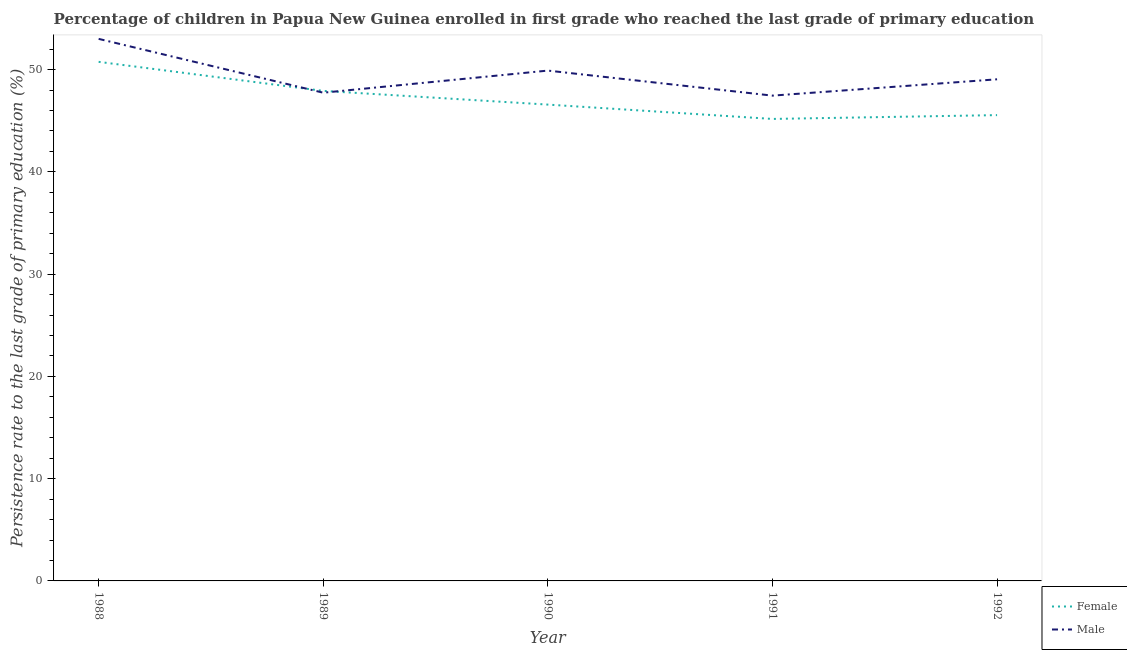What is the persistence rate of female students in 1988?
Your response must be concise. 50.76. Across all years, what is the maximum persistence rate of female students?
Your answer should be compact. 50.76. Across all years, what is the minimum persistence rate of female students?
Ensure brevity in your answer.  45.18. In which year was the persistence rate of female students maximum?
Your answer should be very brief. 1988. In which year was the persistence rate of male students minimum?
Give a very brief answer. 1991. What is the total persistence rate of male students in the graph?
Make the answer very short. 247.16. What is the difference between the persistence rate of female students in 1988 and that in 1992?
Offer a terse response. 5.21. What is the difference between the persistence rate of male students in 1991 and the persistence rate of female students in 1990?
Your answer should be very brief. 0.88. What is the average persistence rate of male students per year?
Offer a terse response. 49.43. In the year 1988, what is the difference between the persistence rate of male students and persistence rate of female students?
Keep it short and to the point. 2.25. In how many years, is the persistence rate of female students greater than 16 %?
Provide a succinct answer. 5. What is the ratio of the persistence rate of male students in 1989 to that in 1992?
Your response must be concise. 0.97. Is the difference between the persistence rate of male students in 1988 and 1991 greater than the difference between the persistence rate of female students in 1988 and 1991?
Your response must be concise. No. What is the difference between the highest and the second highest persistence rate of male students?
Provide a short and direct response. 3.1. What is the difference between the highest and the lowest persistence rate of female students?
Keep it short and to the point. 5.58. In how many years, is the persistence rate of female students greater than the average persistence rate of female students taken over all years?
Offer a very short reply. 2. Is the persistence rate of male students strictly greater than the persistence rate of female students over the years?
Your response must be concise. No. Is the persistence rate of female students strictly less than the persistence rate of male students over the years?
Give a very brief answer. No. Does the graph contain any zero values?
Provide a succinct answer. No. Does the graph contain grids?
Provide a succinct answer. No. What is the title of the graph?
Your answer should be very brief. Percentage of children in Papua New Guinea enrolled in first grade who reached the last grade of primary education. What is the label or title of the X-axis?
Your answer should be very brief. Year. What is the label or title of the Y-axis?
Your answer should be very brief. Persistence rate to the last grade of primary education (%). What is the Persistence rate to the last grade of primary education (%) of Female in 1988?
Your response must be concise. 50.76. What is the Persistence rate to the last grade of primary education (%) in Male in 1988?
Keep it short and to the point. 53.01. What is the Persistence rate to the last grade of primary education (%) in Female in 1989?
Provide a succinct answer. 47.92. What is the Persistence rate to the last grade of primary education (%) in Male in 1989?
Ensure brevity in your answer.  47.74. What is the Persistence rate to the last grade of primary education (%) of Female in 1990?
Ensure brevity in your answer.  46.58. What is the Persistence rate to the last grade of primary education (%) in Male in 1990?
Keep it short and to the point. 49.9. What is the Persistence rate to the last grade of primary education (%) in Female in 1991?
Your response must be concise. 45.18. What is the Persistence rate to the last grade of primary education (%) of Male in 1991?
Make the answer very short. 47.46. What is the Persistence rate to the last grade of primary education (%) of Female in 1992?
Ensure brevity in your answer.  45.55. What is the Persistence rate to the last grade of primary education (%) in Male in 1992?
Offer a very short reply. 49.05. Across all years, what is the maximum Persistence rate to the last grade of primary education (%) in Female?
Give a very brief answer. 50.76. Across all years, what is the maximum Persistence rate to the last grade of primary education (%) of Male?
Your answer should be very brief. 53.01. Across all years, what is the minimum Persistence rate to the last grade of primary education (%) in Female?
Your answer should be very brief. 45.18. Across all years, what is the minimum Persistence rate to the last grade of primary education (%) of Male?
Offer a very short reply. 47.46. What is the total Persistence rate to the last grade of primary education (%) of Female in the graph?
Your answer should be compact. 235.98. What is the total Persistence rate to the last grade of primary education (%) in Male in the graph?
Offer a terse response. 247.16. What is the difference between the Persistence rate to the last grade of primary education (%) in Female in 1988 and that in 1989?
Ensure brevity in your answer.  2.84. What is the difference between the Persistence rate to the last grade of primary education (%) in Male in 1988 and that in 1989?
Provide a succinct answer. 5.26. What is the difference between the Persistence rate to the last grade of primary education (%) in Female in 1988 and that in 1990?
Provide a short and direct response. 4.18. What is the difference between the Persistence rate to the last grade of primary education (%) of Male in 1988 and that in 1990?
Keep it short and to the point. 3.1. What is the difference between the Persistence rate to the last grade of primary education (%) in Female in 1988 and that in 1991?
Provide a short and direct response. 5.58. What is the difference between the Persistence rate to the last grade of primary education (%) of Male in 1988 and that in 1991?
Give a very brief answer. 5.55. What is the difference between the Persistence rate to the last grade of primary education (%) of Female in 1988 and that in 1992?
Provide a short and direct response. 5.21. What is the difference between the Persistence rate to the last grade of primary education (%) in Male in 1988 and that in 1992?
Give a very brief answer. 3.95. What is the difference between the Persistence rate to the last grade of primary education (%) of Female in 1989 and that in 1990?
Your response must be concise. 1.34. What is the difference between the Persistence rate to the last grade of primary education (%) of Male in 1989 and that in 1990?
Provide a succinct answer. -2.16. What is the difference between the Persistence rate to the last grade of primary education (%) in Female in 1989 and that in 1991?
Ensure brevity in your answer.  2.74. What is the difference between the Persistence rate to the last grade of primary education (%) of Male in 1989 and that in 1991?
Your answer should be very brief. 0.29. What is the difference between the Persistence rate to the last grade of primary education (%) in Female in 1989 and that in 1992?
Your answer should be compact. 2.37. What is the difference between the Persistence rate to the last grade of primary education (%) in Male in 1989 and that in 1992?
Give a very brief answer. -1.31. What is the difference between the Persistence rate to the last grade of primary education (%) in Female in 1990 and that in 1991?
Give a very brief answer. 1.4. What is the difference between the Persistence rate to the last grade of primary education (%) of Male in 1990 and that in 1991?
Your answer should be very brief. 2.45. What is the difference between the Persistence rate to the last grade of primary education (%) in Female in 1990 and that in 1992?
Ensure brevity in your answer.  1.03. What is the difference between the Persistence rate to the last grade of primary education (%) of Male in 1990 and that in 1992?
Your answer should be very brief. 0.85. What is the difference between the Persistence rate to the last grade of primary education (%) of Female in 1991 and that in 1992?
Provide a short and direct response. -0.37. What is the difference between the Persistence rate to the last grade of primary education (%) of Male in 1991 and that in 1992?
Provide a succinct answer. -1.6. What is the difference between the Persistence rate to the last grade of primary education (%) in Female in 1988 and the Persistence rate to the last grade of primary education (%) in Male in 1989?
Ensure brevity in your answer.  3.02. What is the difference between the Persistence rate to the last grade of primary education (%) of Female in 1988 and the Persistence rate to the last grade of primary education (%) of Male in 1990?
Ensure brevity in your answer.  0.86. What is the difference between the Persistence rate to the last grade of primary education (%) in Female in 1988 and the Persistence rate to the last grade of primary education (%) in Male in 1991?
Keep it short and to the point. 3.3. What is the difference between the Persistence rate to the last grade of primary education (%) in Female in 1988 and the Persistence rate to the last grade of primary education (%) in Male in 1992?
Offer a terse response. 1.71. What is the difference between the Persistence rate to the last grade of primary education (%) of Female in 1989 and the Persistence rate to the last grade of primary education (%) of Male in 1990?
Your response must be concise. -1.99. What is the difference between the Persistence rate to the last grade of primary education (%) in Female in 1989 and the Persistence rate to the last grade of primary education (%) in Male in 1991?
Provide a short and direct response. 0.46. What is the difference between the Persistence rate to the last grade of primary education (%) in Female in 1989 and the Persistence rate to the last grade of primary education (%) in Male in 1992?
Your answer should be very brief. -1.13. What is the difference between the Persistence rate to the last grade of primary education (%) in Female in 1990 and the Persistence rate to the last grade of primary education (%) in Male in 1991?
Give a very brief answer. -0.88. What is the difference between the Persistence rate to the last grade of primary education (%) of Female in 1990 and the Persistence rate to the last grade of primary education (%) of Male in 1992?
Provide a succinct answer. -2.47. What is the difference between the Persistence rate to the last grade of primary education (%) in Female in 1991 and the Persistence rate to the last grade of primary education (%) in Male in 1992?
Offer a terse response. -3.88. What is the average Persistence rate to the last grade of primary education (%) of Female per year?
Keep it short and to the point. 47.2. What is the average Persistence rate to the last grade of primary education (%) of Male per year?
Give a very brief answer. 49.43. In the year 1988, what is the difference between the Persistence rate to the last grade of primary education (%) of Female and Persistence rate to the last grade of primary education (%) of Male?
Keep it short and to the point. -2.25. In the year 1989, what is the difference between the Persistence rate to the last grade of primary education (%) in Female and Persistence rate to the last grade of primary education (%) in Male?
Offer a very short reply. 0.18. In the year 1990, what is the difference between the Persistence rate to the last grade of primary education (%) in Female and Persistence rate to the last grade of primary education (%) in Male?
Give a very brief answer. -3.33. In the year 1991, what is the difference between the Persistence rate to the last grade of primary education (%) of Female and Persistence rate to the last grade of primary education (%) of Male?
Your answer should be compact. -2.28. In the year 1992, what is the difference between the Persistence rate to the last grade of primary education (%) of Female and Persistence rate to the last grade of primary education (%) of Male?
Your response must be concise. -3.5. What is the ratio of the Persistence rate to the last grade of primary education (%) in Female in 1988 to that in 1989?
Your response must be concise. 1.06. What is the ratio of the Persistence rate to the last grade of primary education (%) of Male in 1988 to that in 1989?
Give a very brief answer. 1.11. What is the ratio of the Persistence rate to the last grade of primary education (%) in Female in 1988 to that in 1990?
Keep it short and to the point. 1.09. What is the ratio of the Persistence rate to the last grade of primary education (%) of Male in 1988 to that in 1990?
Offer a very short reply. 1.06. What is the ratio of the Persistence rate to the last grade of primary education (%) in Female in 1988 to that in 1991?
Your answer should be very brief. 1.12. What is the ratio of the Persistence rate to the last grade of primary education (%) in Male in 1988 to that in 1991?
Make the answer very short. 1.12. What is the ratio of the Persistence rate to the last grade of primary education (%) in Female in 1988 to that in 1992?
Give a very brief answer. 1.11. What is the ratio of the Persistence rate to the last grade of primary education (%) in Male in 1988 to that in 1992?
Your response must be concise. 1.08. What is the ratio of the Persistence rate to the last grade of primary education (%) in Female in 1989 to that in 1990?
Keep it short and to the point. 1.03. What is the ratio of the Persistence rate to the last grade of primary education (%) of Male in 1989 to that in 1990?
Keep it short and to the point. 0.96. What is the ratio of the Persistence rate to the last grade of primary education (%) in Female in 1989 to that in 1991?
Your answer should be very brief. 1.06. What is the ratio of the Persistence rate to the last grade of primary education (%) of Male in 1989 to that in 1991?
Give a very brief answer. 1.01. What is the ratio of the Persistence rate to the last grade of primary education (%) in Female in 1989 to that in 1992?
Your answer should be compact. 1.05. What is the ratio of the Persistence rate to the last grade of primary education (%) in Male in 1989 to that in 1992?
Offer a terse response. 0.97. What is the ratio of the Persistence rate to the last grade of primary education (%) in Female in 1990 to that in 1991?
Your response must be concise. 1.03. What is the ratio of the Persistence rate to the last grade of primary education (%) of Male in 1990 to that in 1991?
Your response must be concise. 1.05. What is the ratio of the Persistence rate to the last grade of primary education (%) in Female in 1990 to that in 1992?
Offer a very short reply. 1.02. What is the ratio of the Persistence rate to the last grade of primary education (%) of Male in 1990 to that in 1992?
Ensure brevity in your answer.  1.02. What is the ratio of the Persistence rate to the last grade of primary education (%) in Male in 1991 to that in 1992?
Offer a very short reply. 0.97. What is the difference between the highest and the second highest Persistence rate to the last grade of primary education (%) of Female?
Provide a short and direct response. 2.84. What is the difference between the highest and the second highest Persistence rate to the last grade of primary education (%) of Male?
Your answer should be compact. 3.1. What is the difference between the highest and the lowest Persistence rate to the last grade of primary education (%) in Female?
Make the answer very short. 5.58. What is the difference between the highest and the lowest Persistence rate to the last grade of primary education (%) in Male?
Your answer should be compact. 5.55. 